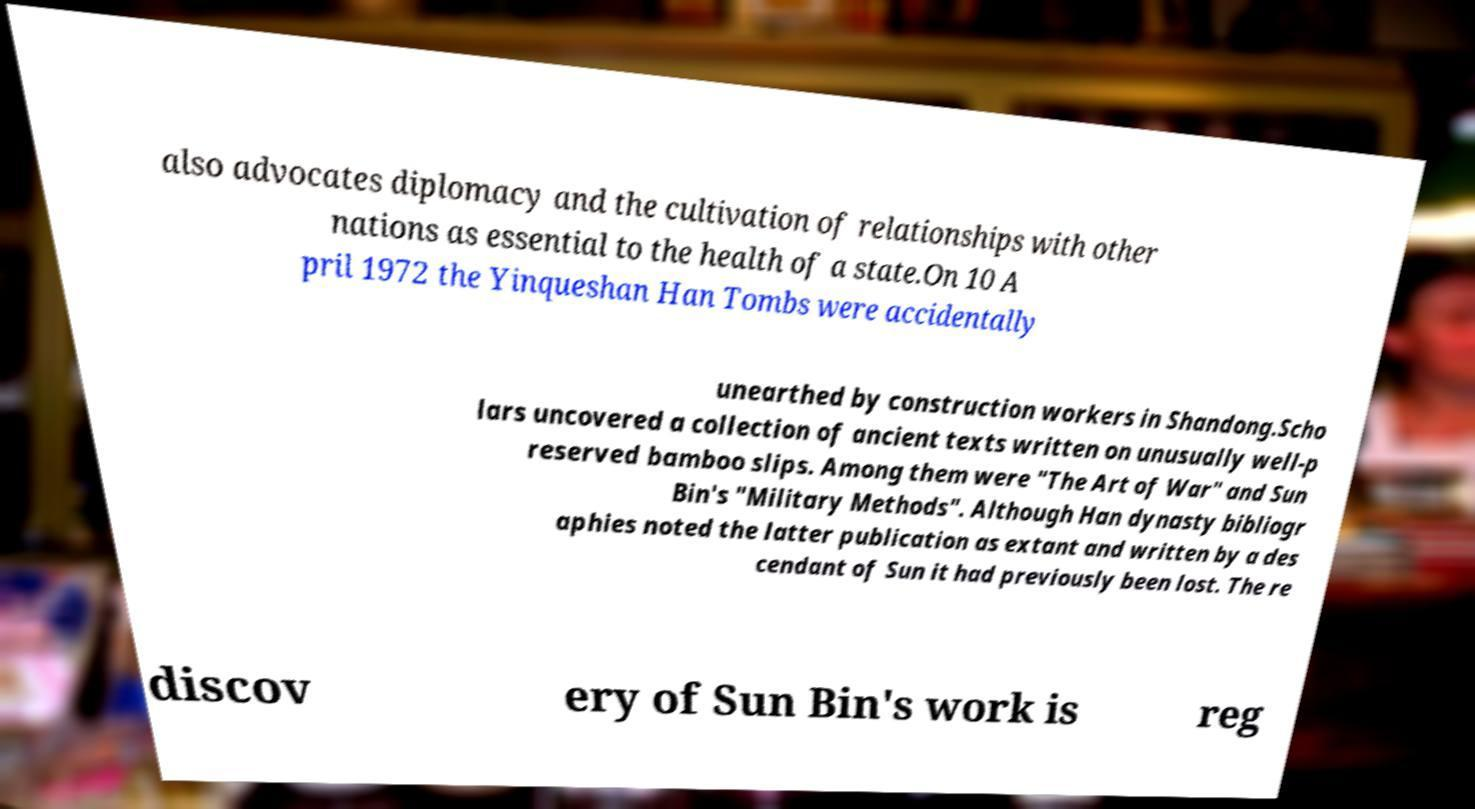I need the written content from this picture converted into text. Can you do that? also advocates diplomacy and the cultivation of relationships with other nations as essential to the health of a state.On 10 A pril 1972 the Yinqueshan Han Tombs were accidentally unearthed by construction workers in Shandong.Scho lars uncovered a collection of ancient texts written on unusually well-p reserved bamboo slips. Among them were "The Art of War" and Sun Bin's "Military Methods". Although Han dynasty bibliogr aphies noted the latter publication as extant and written by a des cendant of Sun it had previously been lost. The re discov ery of Sun Bin's work is reg 